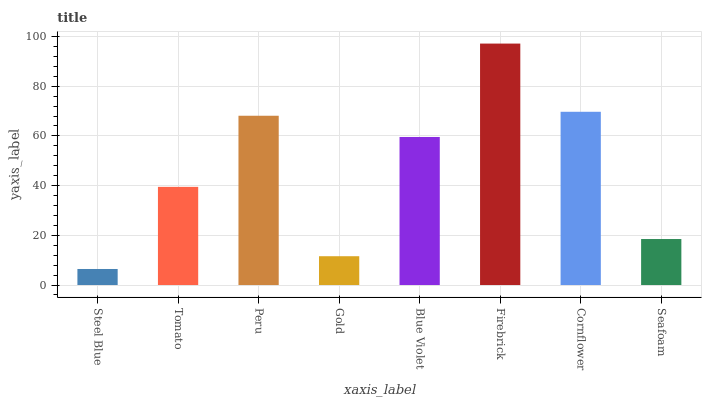Is Steel Blue the minimum?
Answer yes or no. Yes. Is Firebrick the maximum?
Answer yes or no. Yes. Is Tomato the minimum?
Answer yes or no. No. Is Tomato the maximum?
Answer yes or no. No. Is Tomato greater than Steel Blue?
Answer yes or no. Yes. Is Steel Blue less than Tomato?
Answer yes or no. Yes. Is Steel Blue greater than Tomato?
Answer yes or no. No. Is Tomato less than Steel Blue?
Answer yes or no. No. Is Blue Violet the high median?
Answer yes or no. Yes. Is Tomato the low median?
Answer yes or no. Yes. Is Firebrick the high median?
Answer yes or no. No. Is Gold the low median?
Answer yes or no. No. 